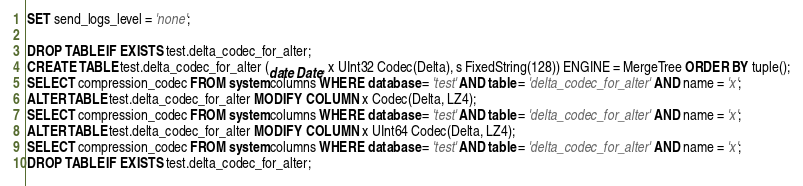<code> <loc_0><loc_0><loc_500><loc_500><_SQL_>SET send_logs_level = 'none';

DROP TABLE IF EXISTS test.delta_codec_for_alter;
CREATE TABLE test.delta_codec_for_alter (date Date, x UInt32 Codec(Delta), s FixedString(128)) ENGINE = MergeTree ORDER BY tuple();
SELECT compression_codec FROM system.columns WHERE database = 'test' AND table = 'delta_codec_for_alter' AND name = 'x';
ALTER TABLE test.delta_codec_for_alter MODIFY COLUMN x Codec(Delta, LZ4);
SELECT compression_codec FROM system.columns WHERE database = 'test' AND table = 'delta_codec_for_alter' AND name = 'x';
ALTER TABLE test.delta_codec_for_alter MODIFY COLUMN x UInt64 Codec(Delta, LZ4);
SELECT compression_codec FROM system.columns WHERE database = 'test' AND table = 'delta_codec_for_alter' AND name = 'x';
DROP TABLE IF EXISTS test.delta_codec_for_alter;
</code> 